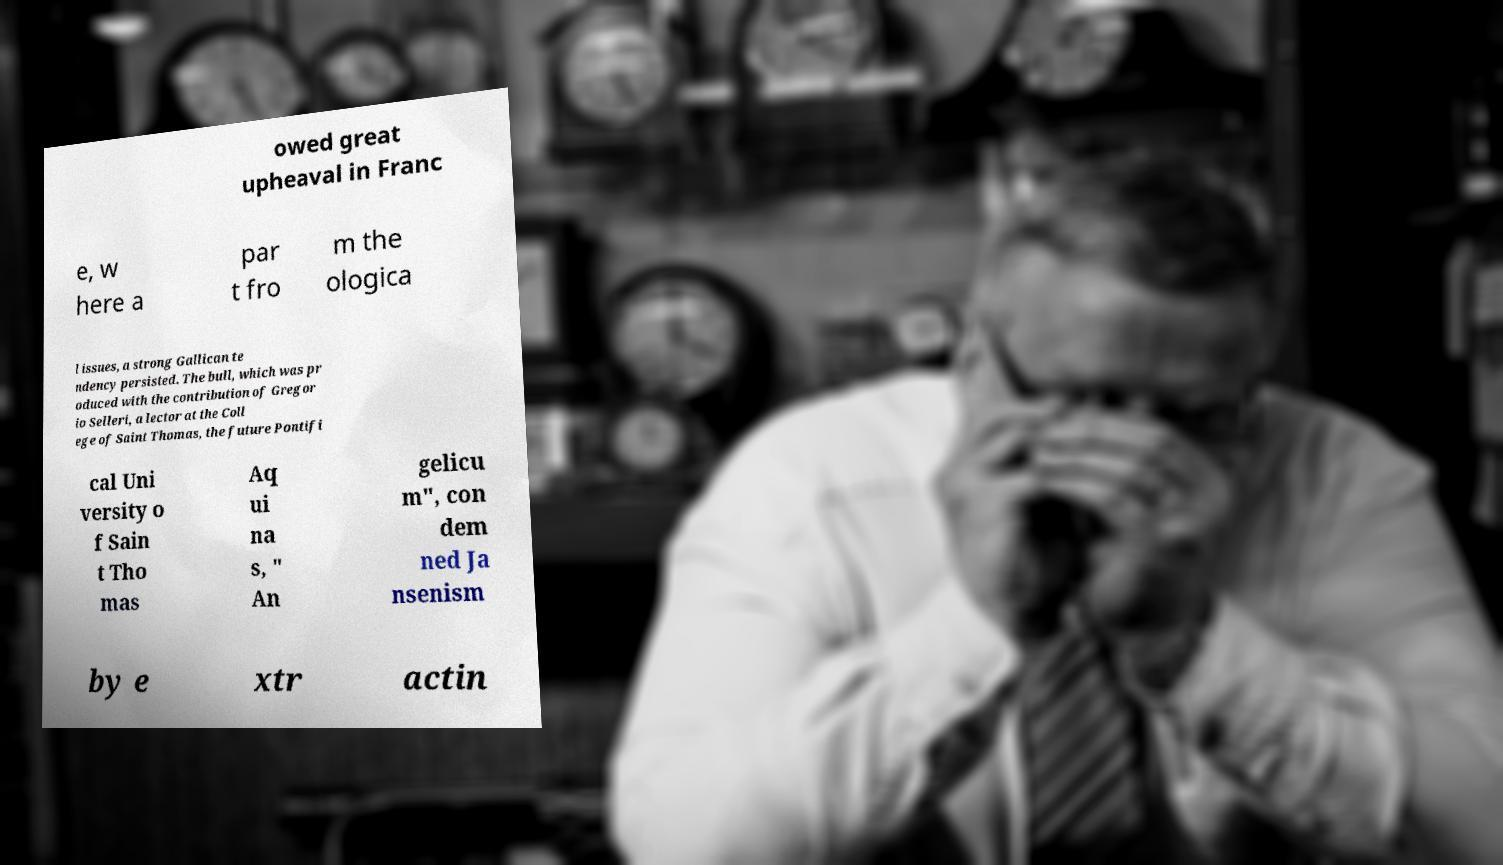Could you assist in decoding the text presented in this image and type it out clearly? owed great upheaval in Franc e, w here a par t fro m the ologica l issues, a strong Gallican te ndency persisted. The bull, which was pr oduced with the contribution of Gregor io Selleri, a lector at the Coll ege of Saint Thomas, the future Pontifi cal Uni versity o f Sain t Tho mas Aq ui na s, " An gelicu m", con dem ned Ja nsenism by e xtr actin 